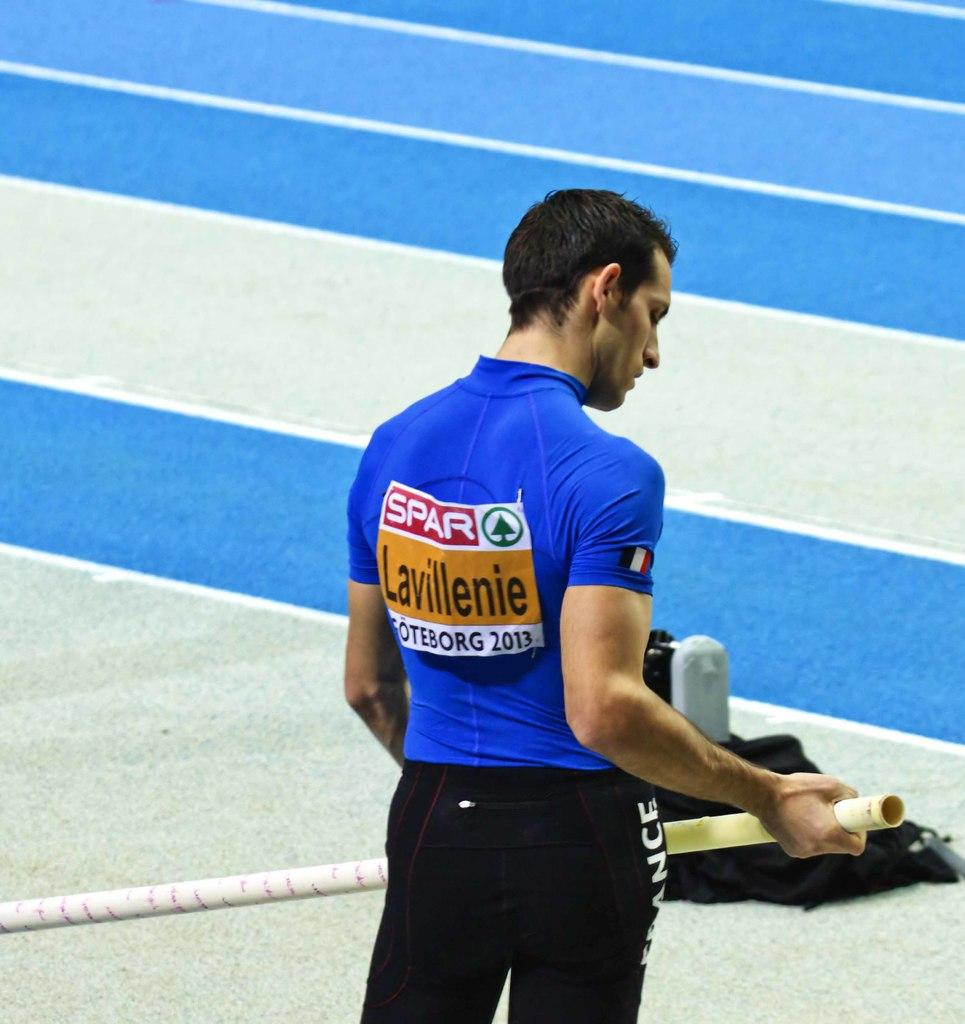Provide a one-sentence caption for the provided image. A young man in a blue shirt with the words Lavillenie on the back is at a pole vaulting event. 